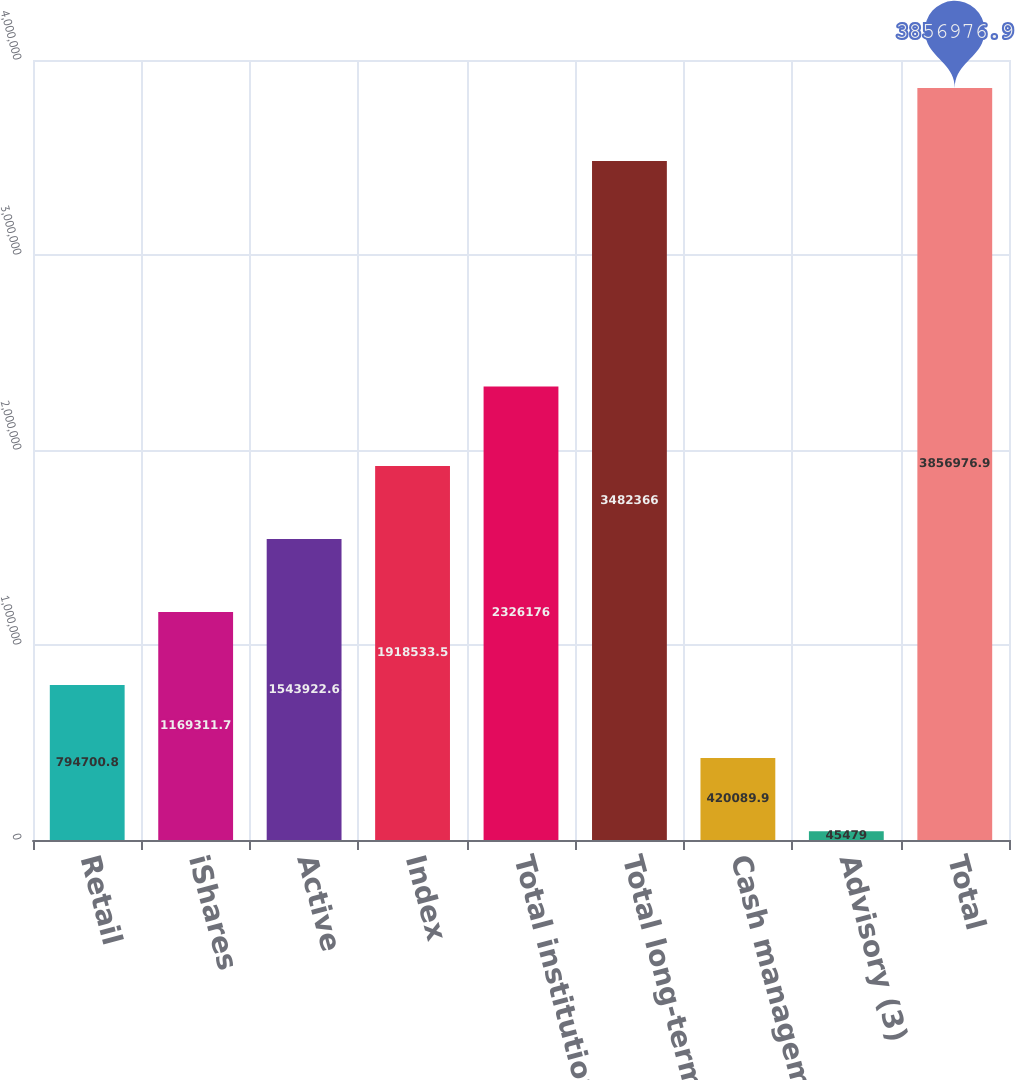Convert chart. <chart><loc_0><loc_0><loc_500><loc_500><bar_chart><fcel>Retail<fcel>iShares<fcel>Active<fcel>Index<fcel>Total institutional<fcel>Total long-term<fcel>Cash management<fcel>Advisory (3)<fcel>Total<nl><fcel>794701<fcel>1.16931e+06<fcel>1.54392e+06<fcel>1.91853e+06<fcel>2.32618e+06<fcel>3.48237e+06<fcel>420090<fcel>45479<fcel>3.85698e+06<nl></chart> 